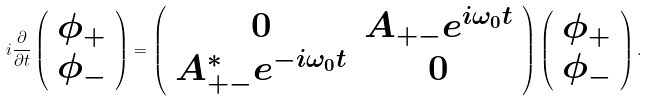<formula> <loc_0><loc_0><loc_500><loc_500>i \frac { \partial } { \partial t } \left ( \begin{array} { c } \phi _ { + } \\ \phi _ { - } \\ \end{array} \right ) = \left ( \begin{array} { c c } 0 & A _ { + - } e ^ { i \omega _ { 0 } t } \\ A _ { + - } ^ { * } e ^ { - i \omega _ { 0 } t } & 0 \\ \end{array} \right ) \left ( \begin{array} { c } \phi _ { + } \\ \phi _ { - } \\ \end{array} \right ) .</formula> 